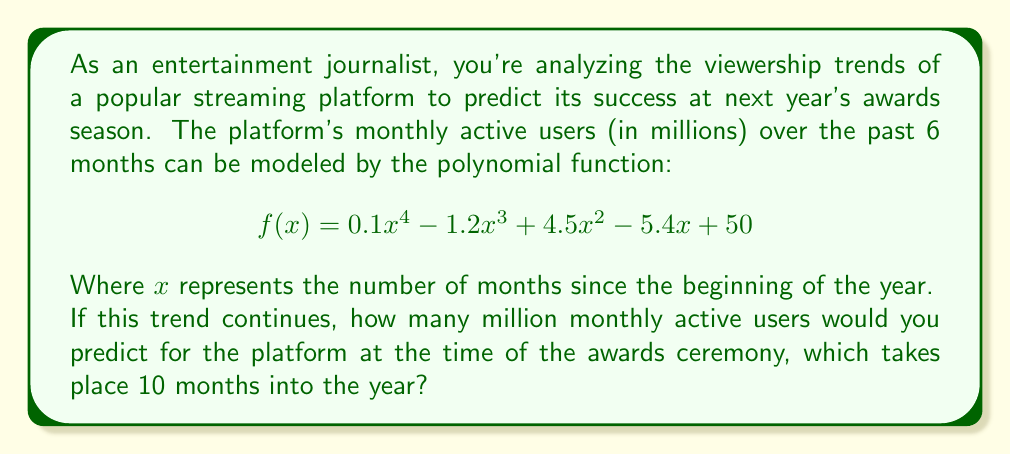Show me your answer to this math problem. To solve this problem, we need to evaluate the given polynomial function at $x = 10$. Let's break it down step-by-step:

1) The function is $f(x) = 0.1x^4 - 1.2x^3 + 4.5x^2 - 5.4x + 50$

2) We need to calculate $f(10)$:

   $f(10) = 0.1(10)^4 - 1.2(10)^3 + 4.5(10)^2 - 5.4(10) + 50$

3) Let's evaluate each term:
   
   $0.1(10)^4 = 0.1 * 10000 = 1000$
   $-1.2(10)^3 = -1.2 * 1000 = -1200$
   $4.5(10)^2 = 4.5 * 100 = 450$
   $-5.4(10) = -54$
   $50$ remains as is

4) Now, let's sum all these terms:

   $f(10) = 1000 - 1200 + 450 - 54 + 50 = 246$

Therefore, the predicted number of monthly active users after 10 months is 246 million.
Answer: 246 million monthly active users 